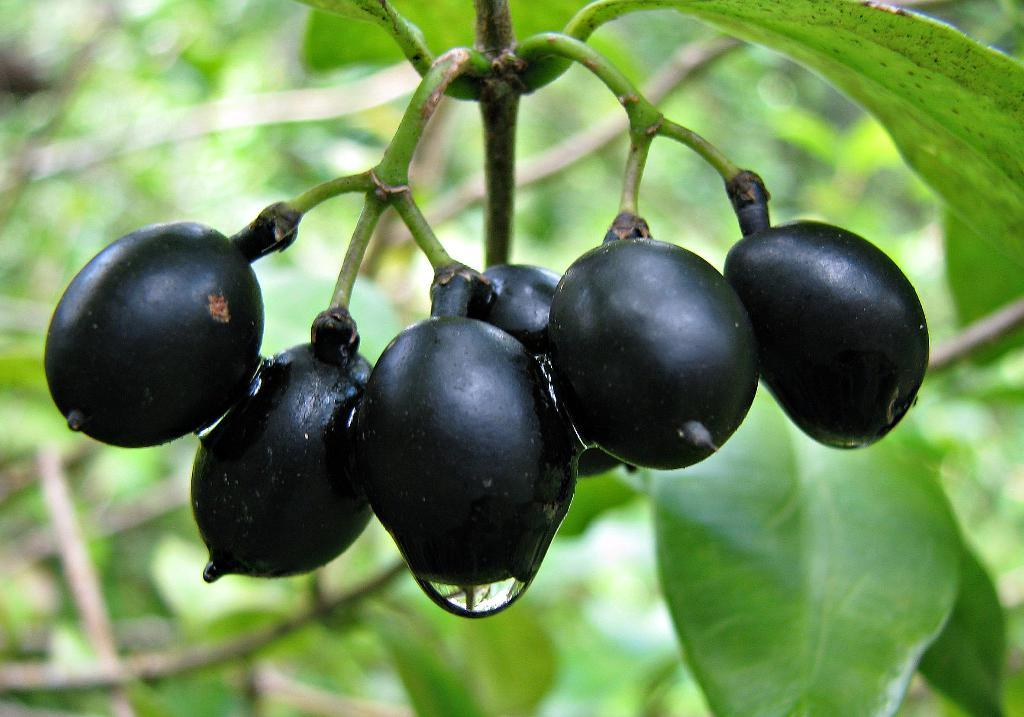Where was the image taken? The image is taken outdoors. What can be seen in the background of the image? There is a tree with green leaves in the background. What is the main subject of the image? The main subject of the image is a few fruits. What color are the fruits? The fruits are black in color. How does the size of the muscle affect the cough in the image? There is no muscle or cough present in the image; it features a few black fruits in the outdoors setting. 